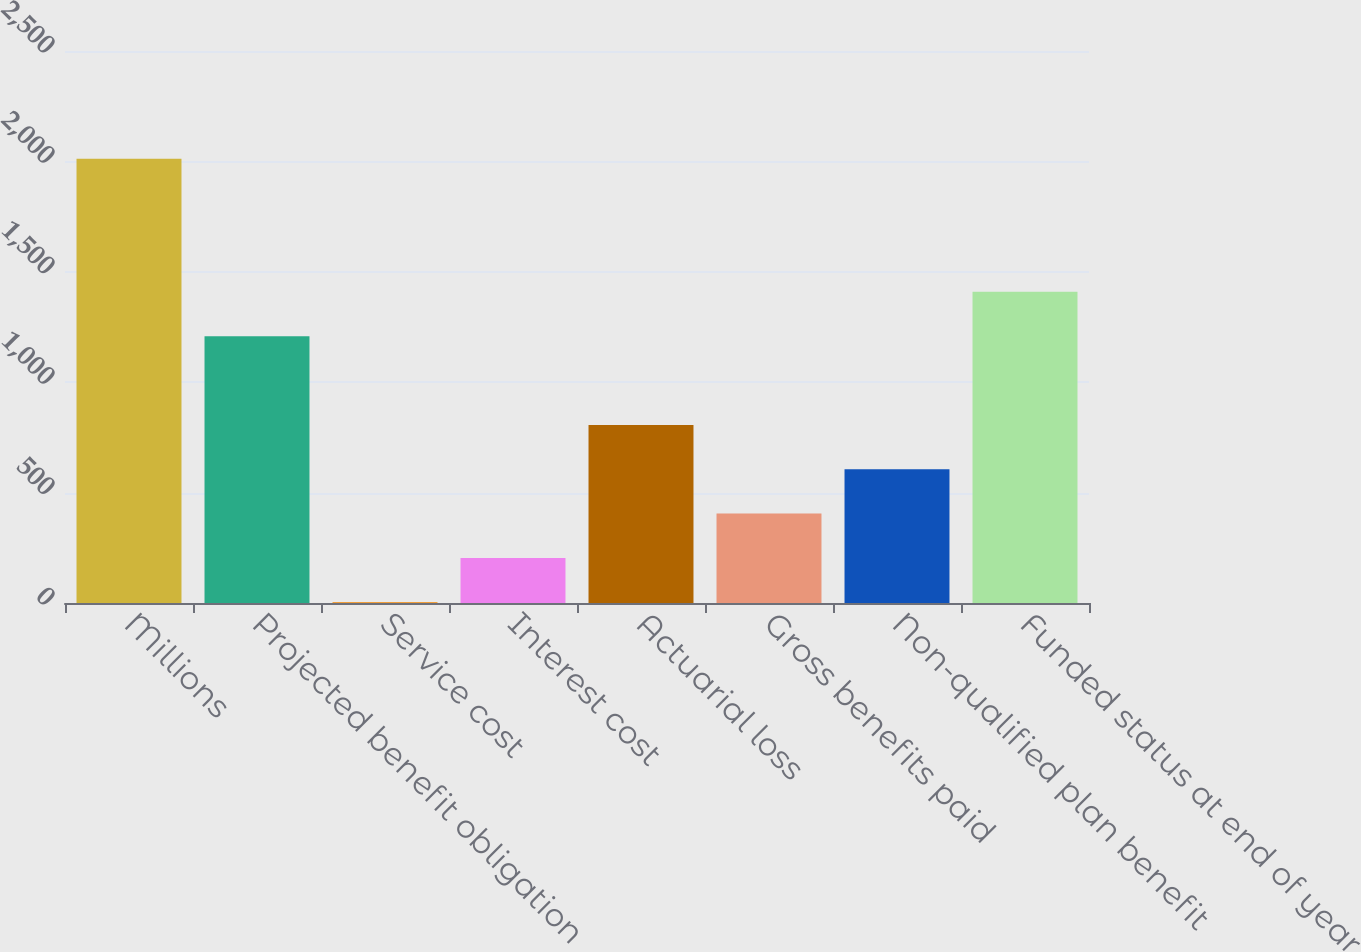<chart> <loc_0><loc_0><loc_500><loc_500><bar_chart><fcel>Millions<fcel>Projected benefit obligation<fcel>Service cost<fcel>Interest cost<fcel>Actuarial loss<fcel>Gross benefits paid<fcel>Non-qualified plan benefit<fcel>Funded status at end of year<nl><fcel>2012<fcel>1208.4<fcel>3<fcel>203.9<fcel>806.6<fcel>404.8<fcel>605.7<fcel>1409.3<nl></chart> 